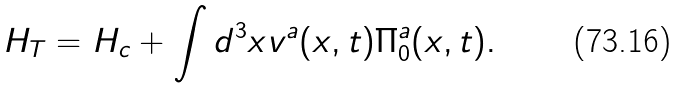Convert formula to latex. <formula><loc_0><loc_0><loc_500><loc_500>H _ { T } = H _ { c } + \int d ^ { 3 } x v ^ { a } ( x , t ) \Pi ^ { a } _ { 0 } ( x , t ) .</formula> 